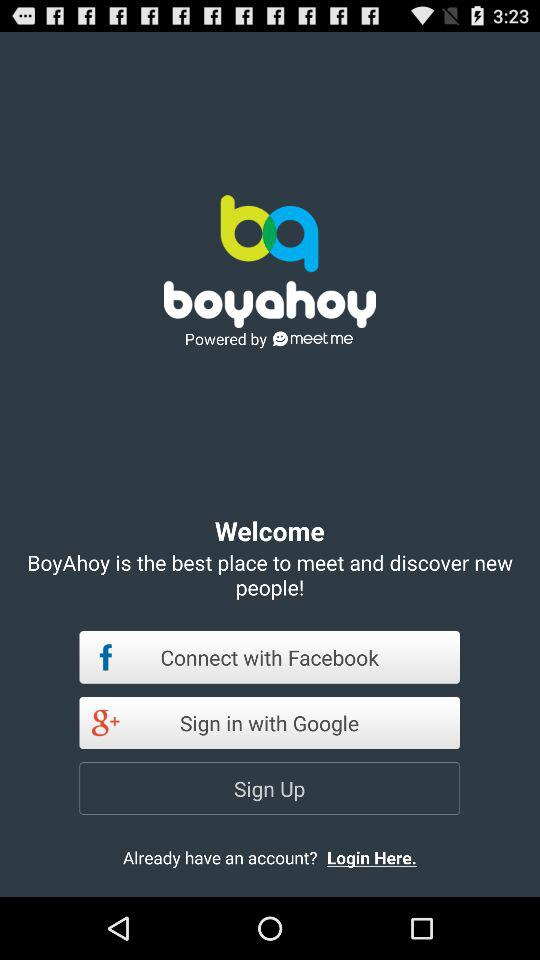What is the name of the application? The name of the application is "boyahoy". 